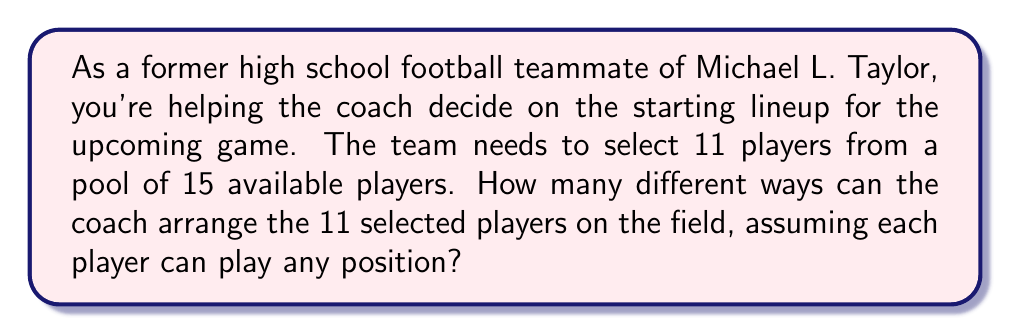What is the answer to this math problem? To solve this problem, we need to break it down into two steps:

1. Selecting 11 players from 15 available players
2. Arranging the 11 selected players on the field

Step 1: Selecting 11 players from 15

This is a combination problem. We use the combination formula:

$${15 \choose 11} = \frac{15!}{11!(15-11)!} = \frac{15!}{11!4!}$$

Step 2: Arranging the 11 selected players

Once we have selected 11 players, we need to arrange them on the field. This is a permutation of 11 players, which is simply 11!

Therefore, the total number of ways to arrange the starting lineup is:

$${15 \choose 11} \cdot 11!$$

Calculating this:

$${15 \choose 11} = \frac{15!}{11!4!} = 1365$$

$$1365 \cdot 11! = 1365 \cdot 39,916,800 = 54,486,432,000$$

Thus, there are 54,486,432,000 different ways to arrange the starting lineup.
Answer: 54,486,432,000 